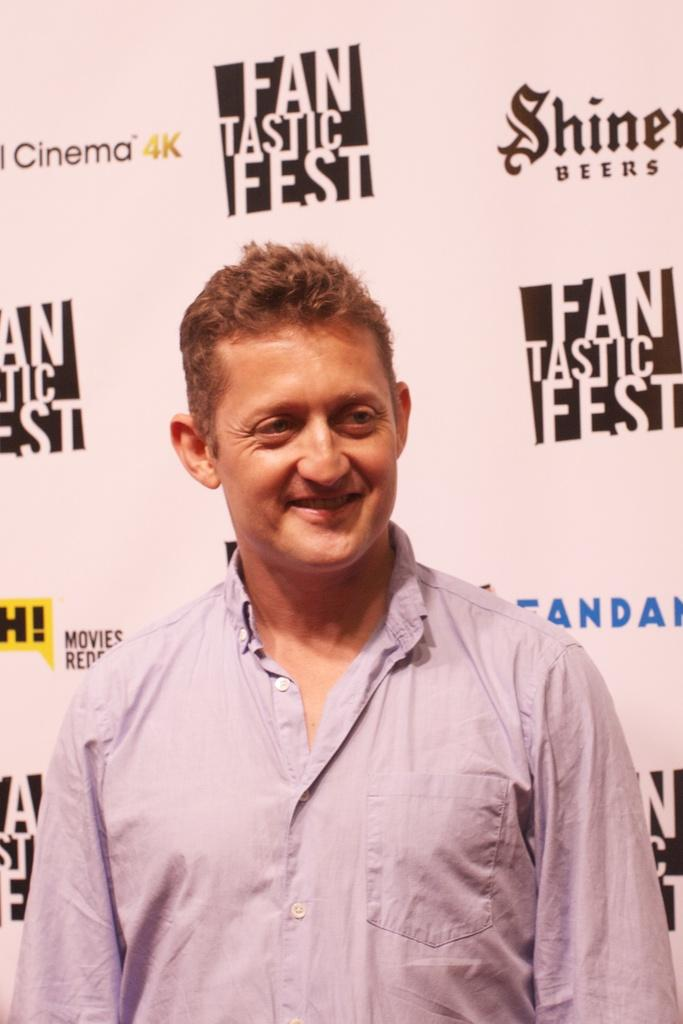<image>
Create a compact narrative representing the image presented. A man is standing in front of a sign that says Fantastic Fest. 